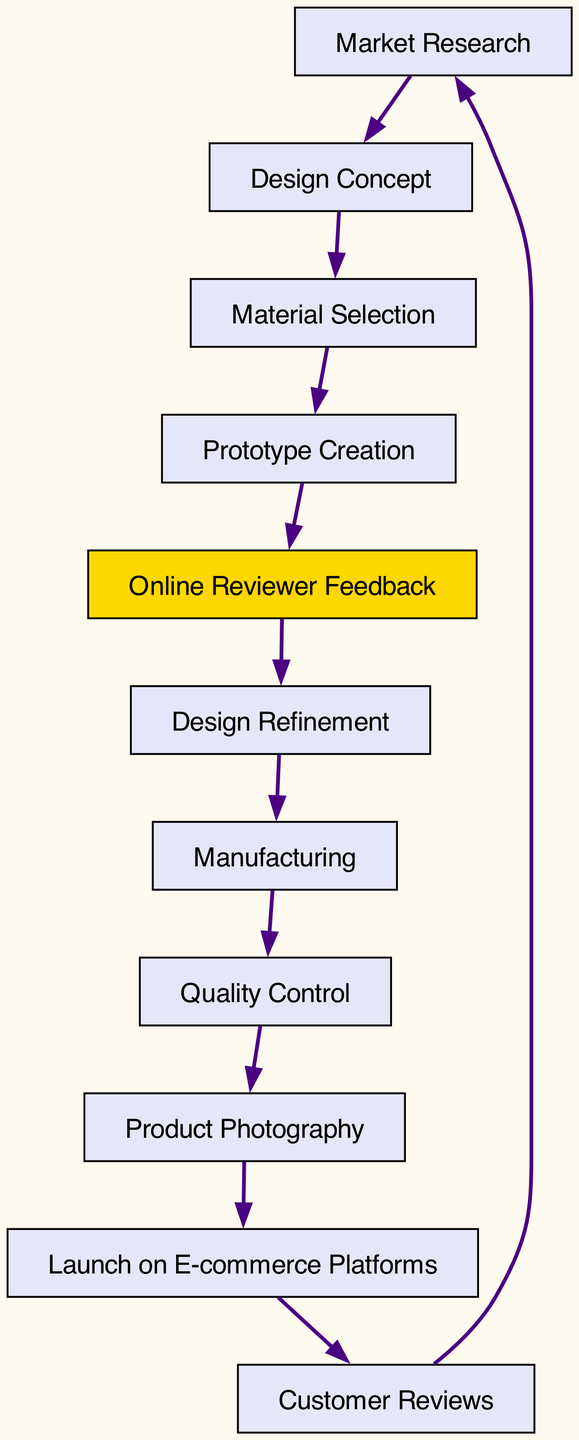What is the first step in the product development lifecycle? The diagram starts with "Market Research" as the first node, indicating that it is the initial step in the lifecycle of product development for the new furniture piece.
Answer: Market Research How many nodes are there in the diagram? The diagram contains ten nodes, as listed under the "nodes" section in the data. Each node represents a step in the product development lifecycle.
Answer: Ten What is the relationship between "Prototype Creation" and "Online Reviewer Feedback"? The diagram shows a directed edge from "Prototype Creation" to "Online Reviewer Feedback," indicating that feedback is gathered after the prototype is created.
Answer: Prototype Creation → Online Reviewer Feedback What is the last step before customer reviews? According to the diagram, the last step before reaching "Customer Reviews" is "Launch on E-commerce Platforms." This indicates that the product is launched before customer feedback is received.
Answer: Launch on E-commerce Platforms Which step directly follows "Design Refinement"? In the directed graph, the edge leading away from "Design Refinement" points to "Manufacturing," illustrating that manufacturing occurs immediately after the design is refined.
Answer: Manufacturing How many edges are present in the diagram? The diagram features ten edges, connecting the various nodes that depict the flow of processes in the product development lifecycle.
Answer: Ten What role does "Online Reviewer Feedback" play in the workflow? "Online Reviewer Feedback" is highlighted in the diagram and serves as a critical part of the flow, connecting directly to "Design Refinement," indicating that feedback influences the design process.
Answer: Design Refinement What is the primary focus of the nodes in this directed graph? The primary focus of all the nodes in this diagram is the development lifecycle of a new modern rustic furniture piece, showcasing each phase from inception to customer feedback.
Answer: Product Development Lifecycle Which node indicates a quality assessment step? The node "Quality Control" indicates the stage in the process where the product is evaluated for its quality before proceeding to the next steps in the development.
Answer: Quality Control 